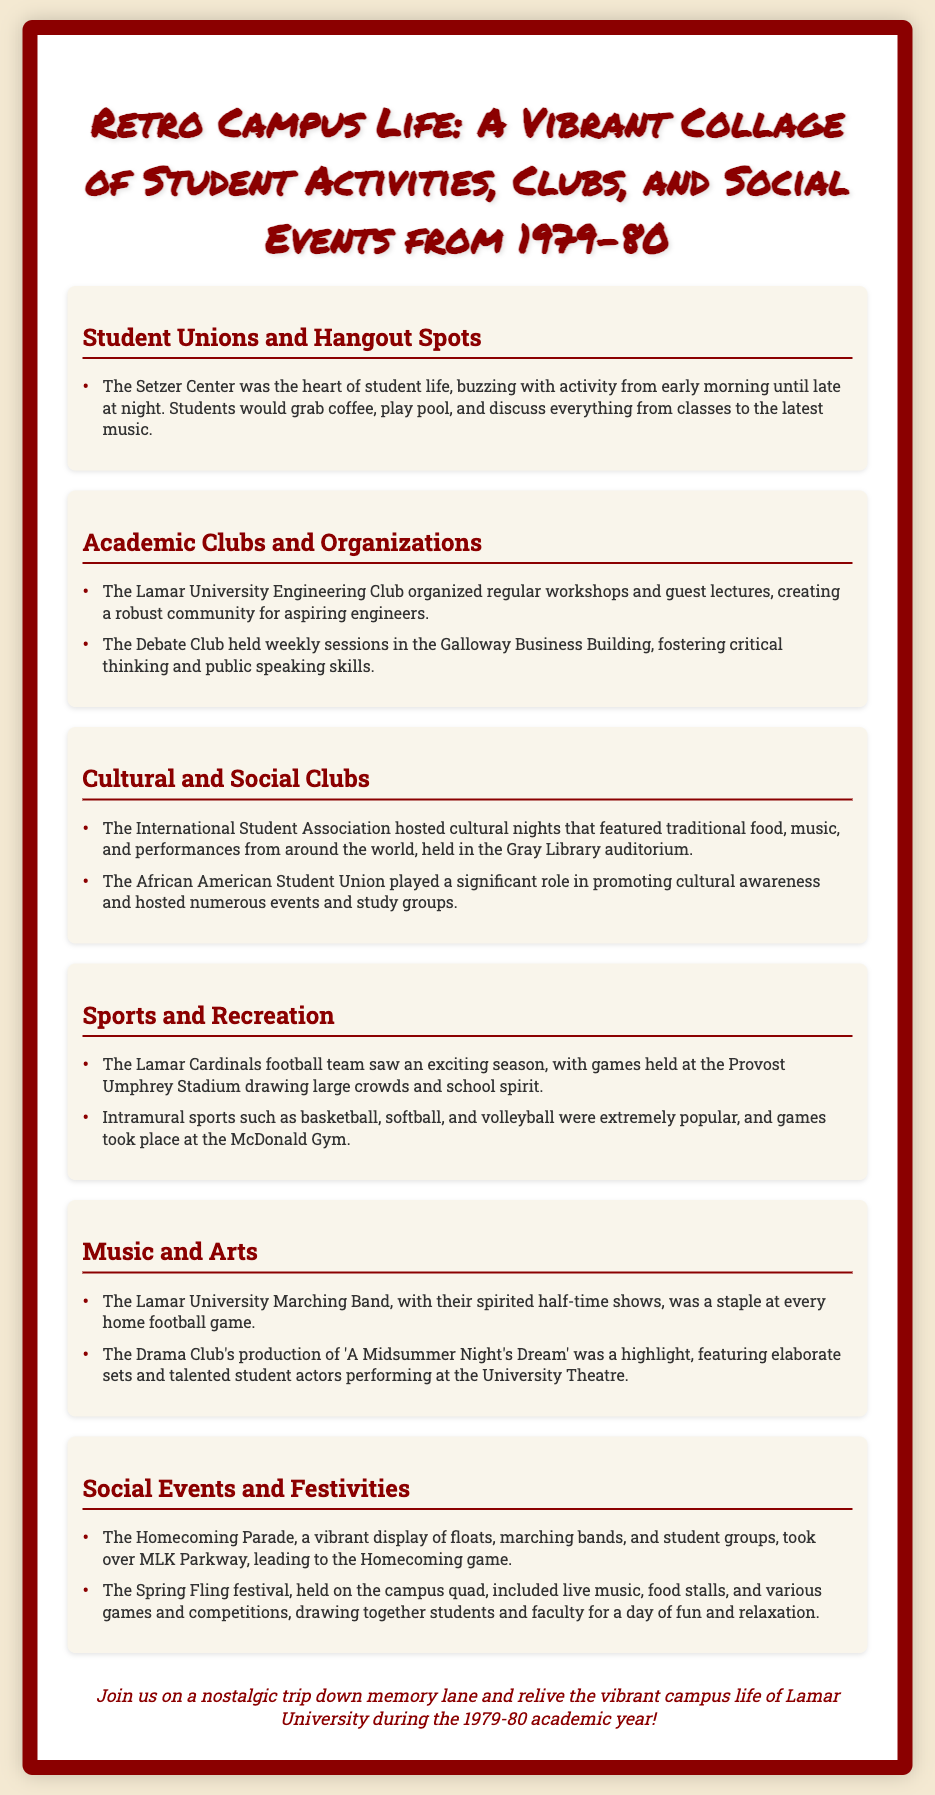What was the heart of student life at Lamar University? The document mentions that the Setzer Center was the heart of student life, buzzing with activity from early morning until late at night.
Answer: The Setzer Center Which club focused on public speaking skills? The Debate Club is noted for holding weekly sessions to foster public speaking skills.
Answer: The Debate Club Where did the International Student Association host cultural nights? Cultural nights organized by the International Student Association were held in the Gray Library auditorium.
Answer: Gray Library auditorium What was a highlight production of the Drama Club? The document lists the production of 'A Midsummer Night's Dream' as a highlight of the Drama Club.
Answer: A Midsummer Night's Dream Which event featured a display of floats and marching bands? The Homecoming Parade is described as a vibrant display of floats, marching bands, and student groups.
Answer: Homecoming Parade How many types of sports were popular in intramural activities? The text mentions that basketball, softball, and volleyball were popular—indicating three types.
Answer: Three What was the name of the festival held on the campus quad? The Spring Fling festival is mentioned as being held on the campus quad with various activities.
Answer: Spring Fling What role did the African American Student Union play? The document states that the African American Student Union played a role in promoting cultural awareness.
Answer: Promoting cultural awareness What was the main activity at the Lamar Cardinals football games? The document highlights that the games drew large crowds and school spirit, indicating the excitement was a key activity.
Answer: School spirit 